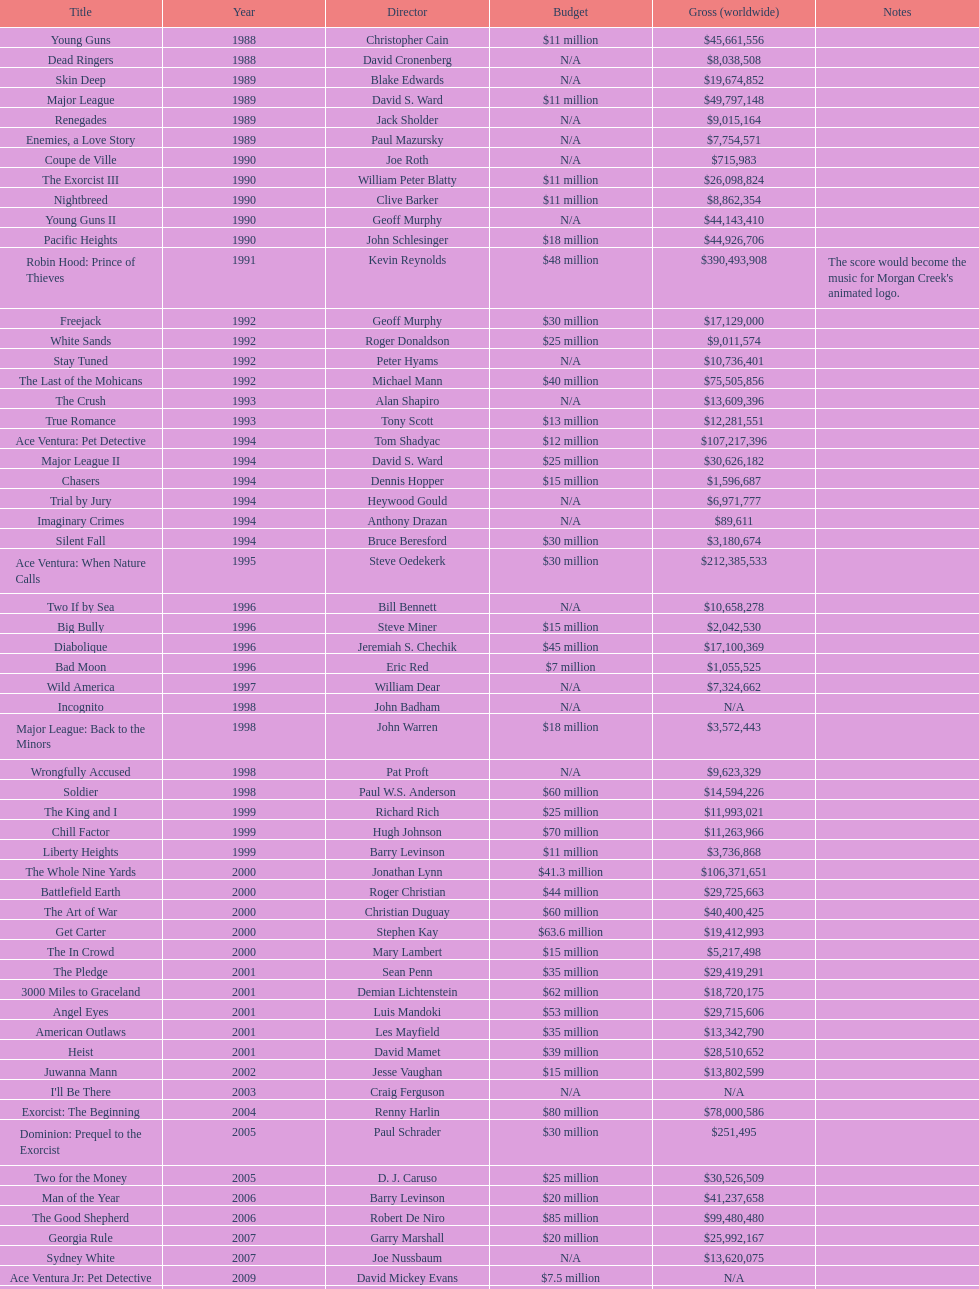Which morgan creek film grossed the most worldwide? Robin Hood: Prince of Thieves. 